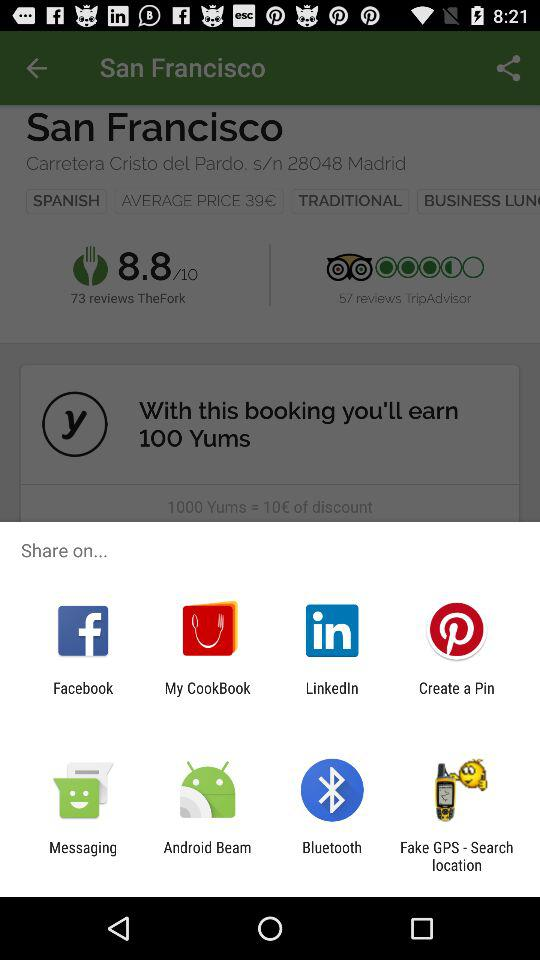How many more reviews does TheFork have than TripAdvisor?
Answer the question using a single word or phrase. 16 